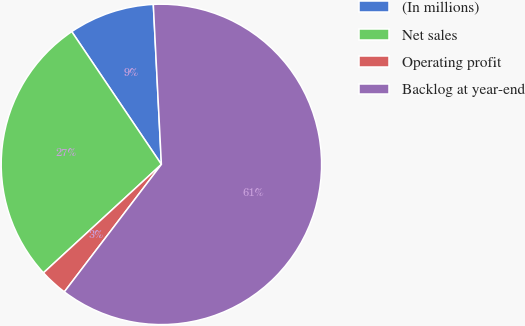Convert chart to OTSL. <chart><loc_0><loc_0><loc_500><loc_500><pie_chart><fcel>(In millions)<fcel>Net sales<fcel>Operating profit<fcel>Backlog at year-end<nl><fcel>8.65%<fcel>27.38%<fcel>2.81%<fcel>61.16%<nl></chart> 